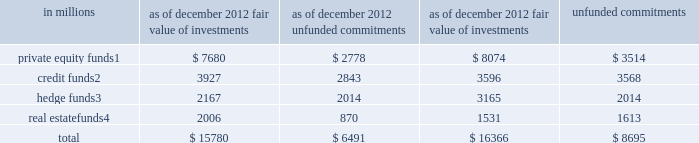Notes to consolidated financial statements investments in funds that calculate net asset value per share cash instruments at fair value include investments in funds that are valued based on the net asset value per share ( nav ) of the investment fund .
The firm uses nav as its measure of fair value for fund investments when ( i ) the fund investment does not have a readily determinable fair value and ( ii ) the nav of the investment fund is calculated in a manner consistent with the measurement principles of investment company accounting , including measurement of the underlying investments at fair value .
The firm 2019s investments in funds that calculate nav primarily consist of investments in firm-sponsored funds where the firm co-invests with third-party investors .
The private equity , credit and real estate funds are primarily closed-end funds in which the firm 2019s investments are not eligible for redemption .
Distributions will be received from these funds as the underlying assets are liquidated and it is estimated that substantially all of the underlying assets of existing funds will be liquidated over the next seven years .
The firm continues to manage its existing funds taking into account the transition periods under the volcker rule of the u.s .
Dodd-frank wall street reform and consumer protection act ( dodd-frank act ) , although the rules have not yet been finalized .
The firm 2019s investments in hedge funds are generally redeemable on a quarterly basis with 91 days 2019 notice , subject to a maximum redemption level of 25% ( 25 % ) of the firm 2019s initial investments at any quarter-end .
The firm currently plans to comply with the volcker rule by redeeming certain of its interests in hedge funds .
The firm redeemed approximately $ 1.06 billion of these interests in hedge funds during the year ended december 2012 .
The table below presents the fair value of the firm 2019s investments in , and unfunded commitments to , funds that calculate nav. .
These funds primarily invest in a broad range of industries worldwide in a variety of situations , including leveraged buyouts , recapitalizations and growth investments .
These funds generally invest in loans and other fixed income instruments and are focused on providing private high-yield capital for mid- to large-sized leveraged and management buyout transactions , recapitalizations , financings , refinancings , acquisitions and restructurings for private equity firms , private family companies and corporate issuers .
These funds are primarily multi-disciplinary hedge funds that employ a fundamental bottom-up investment approach across various asset classes and strategies including long/short equity , credit , convertibles , risk arbitrage , special situations and capital structure arbitrage .
These funds invest globally , primarily in real estate companies , loan portfolios , debt recapitalizations and direct property .
Goldman sachs 2012 annual report 127 .
The firm redeemed approximately $ 1.06 billion of these interests in hedge funds during the year ended december 2012 . what percentage was this of the remaining funds at 12/31/21? 
Computations: (1.06 / (2167 / 1000))
Answer: 0.48916. Notes to consolidated financial statements investments in funds that calculate net asset value per share cash instruments at fair value include investments in funds that are valued based on the net asset value per share ( nav ) of the investment fund .
The firm uses nav as its measure of fair value for fund investments when ( i ) the fund investment does not have a readily determinable fair value and ( ii ) the nav of the investment fund is calculated in a manner consistent with the measurement principles of investment company accounting , including measurement of the underlying investments at fair value .
The firm 2019s investments in funds that calculate nav primarily consist of investments in firm-sponsored funds where the firm co-invests with third-party investors .
The private equity , credit and real estate funds are primarily closed-end funds in which the firm 2019s investments are not eligible for redemption .
Distributions will be received from these funds as the underlying assets are liquidated and it is estimated that substantially all of the underlying assets of existing funds will be liquidated over the next seven years .
The firm continues to manage its existing funds taking into account the transition periods under the volcker rule of the u.s .
Dodd-frank wall street reform and consumer protection act ( dodd-frank act ) , although the rules have not yet been finalized .
The firm 2019s investments in hedge funds are generally redeemable on a quarterly basis with 91 days 2019 notice , subject to a maximum redemption level of 25% ( 25 % ) of the firm 2019s initial investments at any quarter-end .
The firm currently plans to comply with the volcker rule by redeeming certain of its interests in hedge funds .
The firm redeemed approximately $ 1.06 billion of these interests in hedge funds during the year ended december 2012 .
The table below presents the fair value of the firm 2019s investments in , and unfunded commitments to , funds that calculate nav. .
These funds primarily invest in a broad range of industries worldwide in a variety of situations , including leveraged buyouts , recapitalizations and growth investments .
These funds generally invest in loans and other fixed income instruments and are focused on providing private high-yield capital for mid- to large-sized leveraged and management buyout transactions , recapitalizations , financings , refinancings , acquisitions and restructurings for private equity firms , private family companies and corporate issuers .
These funds are primarily multi-disciplinary hedge funds that employ a fundamental bottom-up investment approach across various asset classes and strategies including long/short equity , credit , convertibles , risk arbitrage , special situations and capital structure arbitrage .
These funds invest globally , primarily in real estate companies , loan portfolios , debt recapitalizations and direct property .
Goldman sachs 2012 annual report 127 .
From december 2012 to december 2011 , what was the change in millions in fair value of investments in private equity finds? 
Computations: (8074 - 7680)
Answer: 394.0. Notes to consolidated financial statements investments in funds that calculate net asset value per share cash instruments at fair value include investments in funds that are valued based on the net asset value per share ( nav ) of the investment fund .
The firm uses nav as its measure of fair value for fund investments when ( i ) the fund investment does not have a readily determinable fair value and ( ii ) the nav of the investment fund is calculated in a manner consistent with the measurement principles of investment company accounting , including measurement of the underlying investments at fair value .
The firm 2019s investments in funds that calculate nav primarily consist of investments in firm-sponsored funds where the firm co-invests with third-party investors .
The private equity , credit and real estate funds are primarily closed-end funds in which the firm 2019s investments are not eligible for redemption .
Distributions will be received from these funds as the underlying assets are liquidated and it is estimated that substantially all of the underlying assets of existing funds will be liquidated over the next seven years .
The firm continues to manage its existing funds taking into account the transition periods under the volcker rule of the u.s .
Dodd-frank wall street reform and consumer protection act ( dodd-frank act ) , although the rules have not yet been finalized .
The firm 2019s investments in hedge funds are generally redeemable on a quarterly basis with 91 days 2019 notice , subject to a maximum redemption level of 25% ( 25 % ) of the firm 2019s initial investments at any quarter-end .
The firm currently plans to comply with the volcker rule by redeeming certain of its interests in hedge funds .
The firm redeemed approximately $ 1.06 billion of these interests in hedge funds during the year ended december 2012 .
The table below presents the fair value of the firm 2019s investments in , and unfunded commitments to , funds that calculate nav. .
These funds primarily invest in a broad range of industries worldwide in a variety of situations , including leveraged buyouts , recapitalizations and growth investments .
These funds generally invest in loans and other fixed income instruments and are focused on providing private high-yield capital for mid- to large-sized leveraged and management buyout transactions , recapitalizations , financings , refinancings , acquisitions and restructurings for private equity firms , private family companies and corporate issuers .
These funds are primarily multi-disciplinary hedge funds that employ a fundamental bottom-up investment approach across various asset classes and strategies including long/short equity , credit , convertibles , risk arbitrage , special situations and capital structure arbitrage .
These funds invest globally , primarily in real estate companies , loan portfolios , debt recapitalizations and direct property .
Goldman sachs 2012 annual report 127 .
What is the growth rate in the fair value of total investments in 2012? 
Computations: ((15780 - 16366) / 16366)
Answer: -0.03581. 